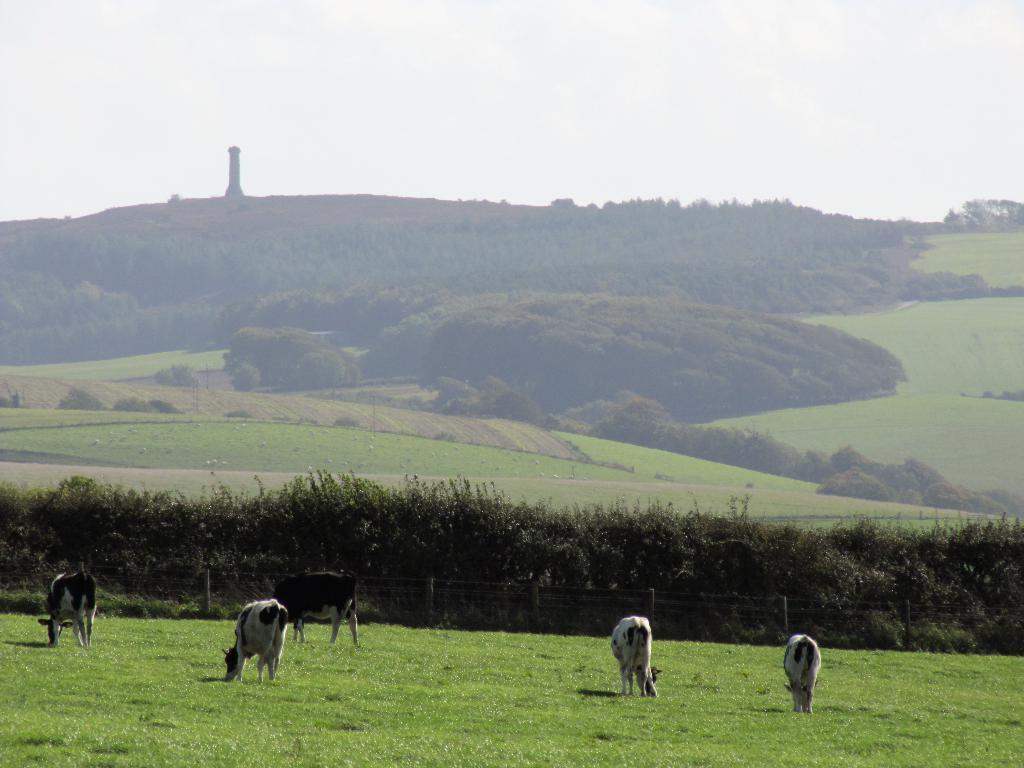Please provide a concise description of this image. In this image there are some cows on the grass as we can see in the bottom of this image. There are some trees in the background. There are some trees as we can see in the middle of this image. There is a sky on the top of this image. 